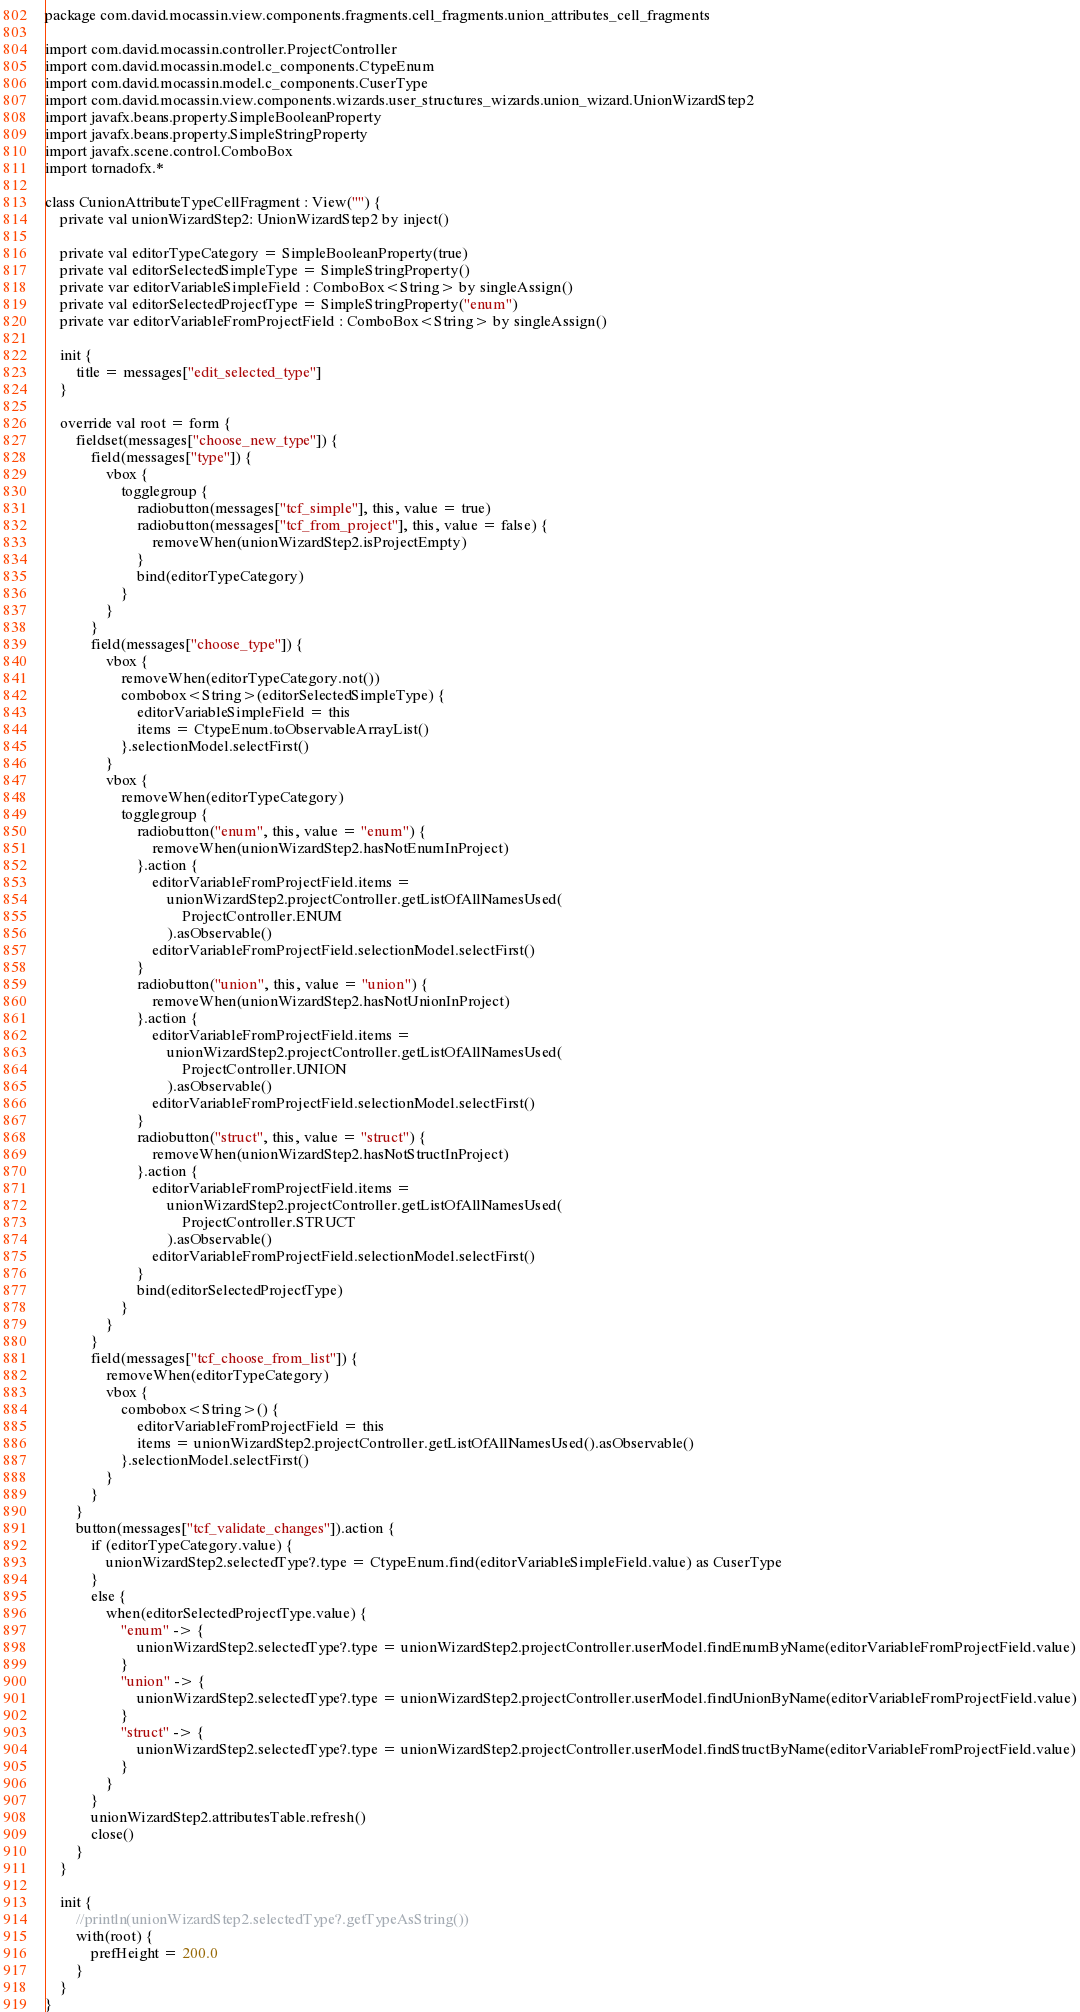Convert code to text. <code><loc_0><loc_0><loc_500><loc_500><_Kotlin_>package com.david.mocassin.view.components.fragments.cell_fragments.union_attributes_cell_fragments

import com.david.mocassin.controller.ProjectController
import com.david.mocassin.model.c_components.CtypeEnum
import com.david.mocassin.model.c_components.CuserType
import com.david.mocassin.view.components.wizards.user_structures_wizards.union_wizard.UnionWizardStep2
import javafx.beans.property.SimpleBooleanProperty
import javafx.beans.property.SimpleStringProperty
import javafx.scene.control.ComboBox
import tornadofx.*

class CunionAttributeTypeCellFragment : View("") {
    private val unionWizardStep2: UnionWizardStep2 by inject()

    private val editorTypeCategory = SimpleBooleanProperty(true)
    private val editorSelectedSimpleType = SimpleStringProperty()
    private var editorVariableSimpleField : ComboBox<String> by singleAssign()
    private val editorSelectedProjectType = SimpleStringProperty("enum")
    private var editorVariableFromProjectField : ComboBox<String> by singleAssign()

    init {
        title = messages["edit_selected_type"]
    }

    override val root = form {
        fieldset(messages["choose_new_type"]) {
            field(messages["type"]) {
                vbox {
                    togglegroup {
                        radiobutton(messages["tcf_simple"], this, value = true)
                        radiobutton(messages["tcf_from_project"], this, value = false) {
                            removeWhen(unionWizardStep2.isProjectEmpty)
                        }
                        bind(editorTypeCategory)
                    }
                }
            }
            field(messages["choose_type"]) {
                vbox {
                    removeWhen(editorTypeCategory.not())
                    combobox<String>(editorSelectedSimpleType) {
                        editorVariableSimpleField = this
                        items = CtypeEnum.toObservableArrayList()
                    }.selectionModel.selectFirst()
                }
                vbox {
                    removeWhen(editorTypeCategory)
                    togglegroup {
                        radiobutton("enum", this, value = "enum") {
                            removeWhen(unionWizardStep2.hasNotEnumInProject)
                        }.action {
                            editorVariableFromProjectField.items =
                                unionWizardStep2.projectController.getListOfAllNamesUsed(
                                    ProjectController.ENUM
                                ).asObservable()
                            editorVariableFromProjectField.selectionModel.selectFirst()
                        }
                        radiobutton("union", this, value = "union") {
                            removeWhen(unionWizardStep2.hasNotUnionInProject)
                        }.action {
                            editorVariableFromProjectField.items =
                                unionWizardStep2.projectController.getListOfAllNamesUsed(
                                    ProjectController.UNION
                                ).asObservable()
                            editorVariableFromProjectField.selectionModel.selectFirst()
                        }
                        radiobutton("struct", this, value = "struct") {
                            removeWhen(unionWizardStep2.hasNotStructInProject)
                        }.action {
                            editorVariableFromProjectField.items =
                                unionWizardStep2.projectController.getListOfAllNamesUsed(
                                    ProjectController.STRUCT
                                ).asObservable()
                            editorVariableFromProjectField.selectionModel.selectFirst()
                        }
                        bind(editorSelectedProjectType)
                    }
                }
            }
            field(messages["tcf_choose_from_list"]) {
                removeWhen(editorTypeCategory)
                vbox {
                    combobox<String>() {
                        editorVariableFromProjectField = this
                        items = unionWizardStep2.projectController.getListOfAllNamesUsed().asObservable()
                    }.selectionModel.selectFirst()
                }
            }
        }
        button(messages["tcf_validate_changes"]).action {
            if (editorTypeCategory.value) {
                unionWizardStep2.selectedType?.type = CtypeEnum.find(editorVariableSimpleField.value) as CuserType
            }
            else {
                when(editorSelectedProjectType.value) {
                    "enum" -> {
                        unionWizardStep2.selectedType?.type = unionWizardStep2.projectController.userModel.findEnumByName(editorVariableFromProjectField.value)
                    }
                    "union" -> {
                        unionWizardStep2.selectedType?.type = unionWizardStep2.projectController.userModel.findUnionByName(editorVariableFromProjectField.value)
                    }
                    "struct" -> {
                        unionWizardStep2.selectedType?.type = unionWizardStep2.projectController.userModel.findStructByName(editorVariableFromProjectField.value)
                    }
                }
            }
            unionWizardStep2.attributesTable.refresh()
            close()
        }
    }

    init {
        //println(unionWizardStep2.selectedType?.getTypeAsString())
        with(root) {
            prefHeight = 200.0
        }
    }
}</code> 